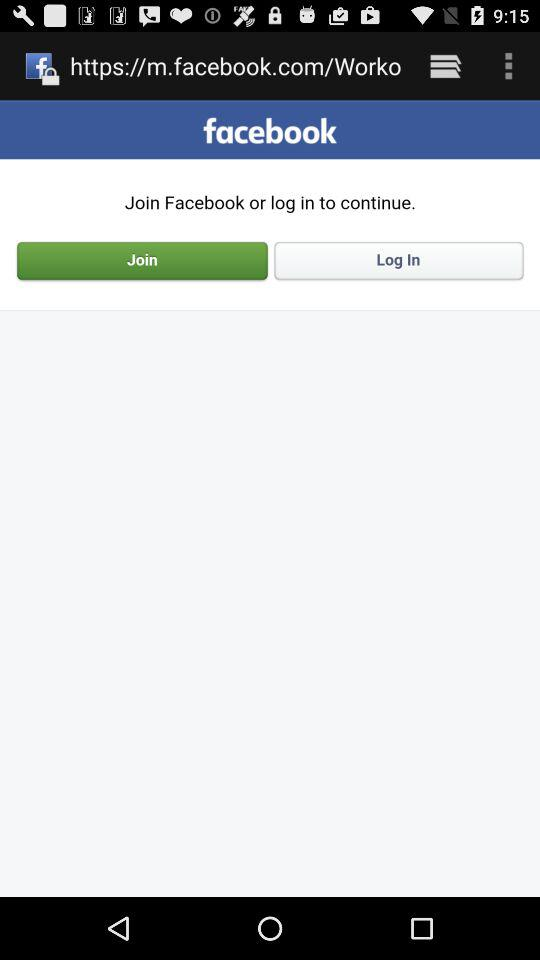What is the name of the application? The name of the application is "facebook". 